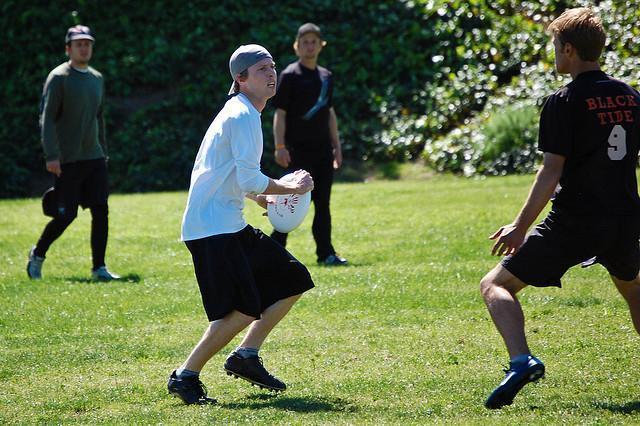How many men are wearing white shirts?
Give a very brief answer. 1. How many people are there?
Give a very brief answer. 4. How many books are pictured?
Give a very brief answer. 0. 